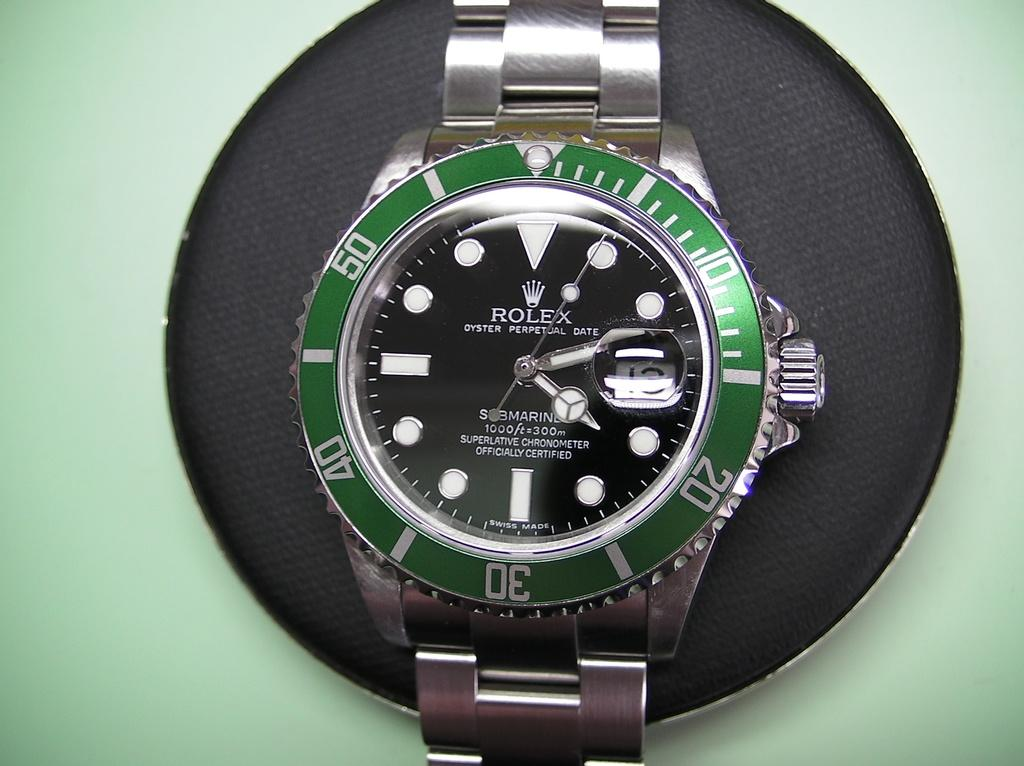Provide a one-sentence caption for the provided image. A Rolex brand watch with a green circle around the face of it. 